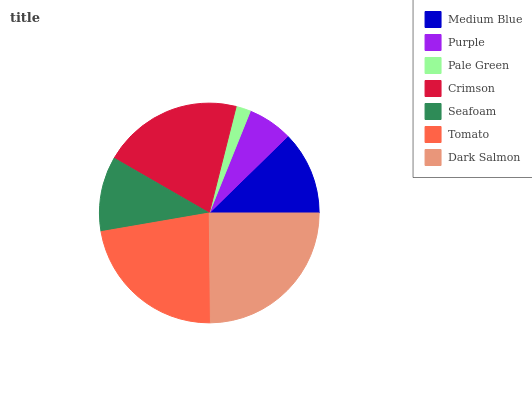Is Pale Green the minimum?
Answer yes or no. Yes. Is Dark Salmon the maximum?
Answer yes or no. Yes. Is Purple the minimum?
Answer yes or no. No. Is Purple the maximum?
Answer yes or no. No. Is Medium Blue greater than Purple?
Answer yes or no. Yes. Is Purple less than Medium Blue?
Answer yes or no. Yes. Is Purple greater than Medium Blue?
Answer yes or no. No. Is Medium Blue less than Purple?
Answer yes or no. No. Is Medium Blue the high median?
Answer yes or no. Yes. Is Medium Blue the low median?
Answer yes or no. Yes. Is Crimson the high median?
Answer yes or no. No. Is Dark Salmon the low median?
Answer yes or no. No. 